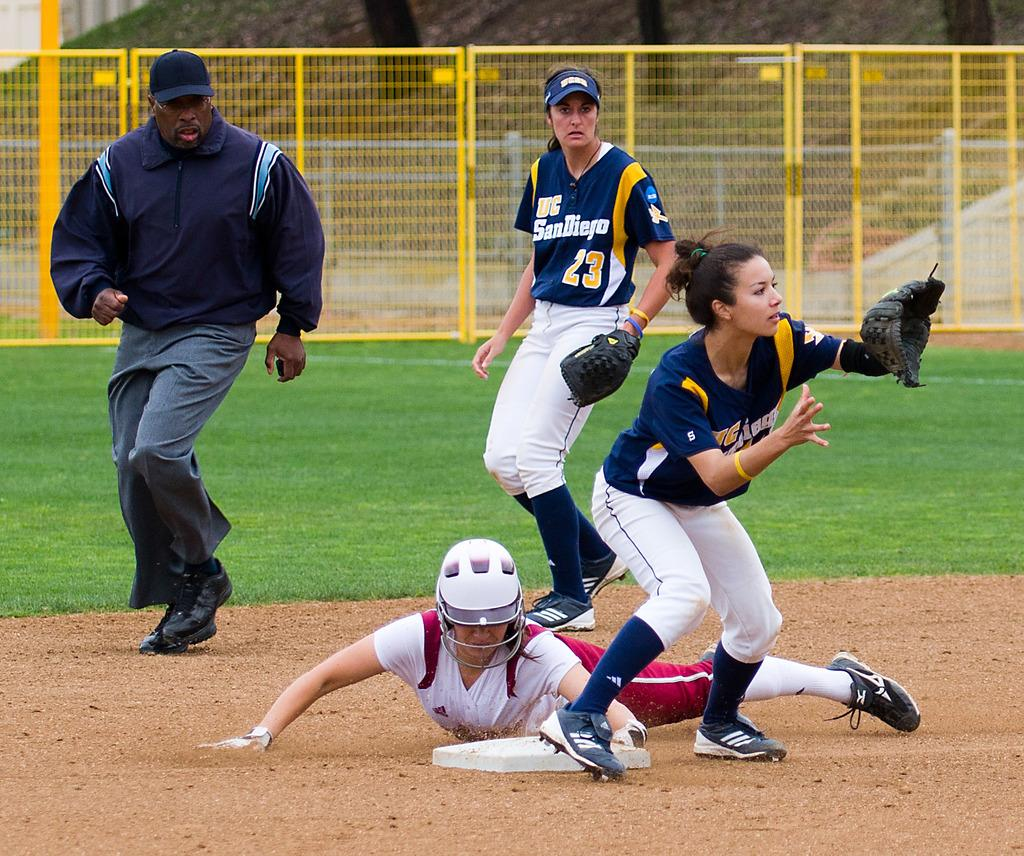<image>
Give a short and clear explanation of the subsequent image. Much to the chagrin of the UC San Diego players, she successfully slid home. 